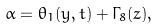Convert formula to latex. <formula><loc_0><loc_0><loc_500><loc_500>\alpha = \theta _ { 1 } ( y , t ) + \Gamma _ { 8 } ( z ) ,</formula> 